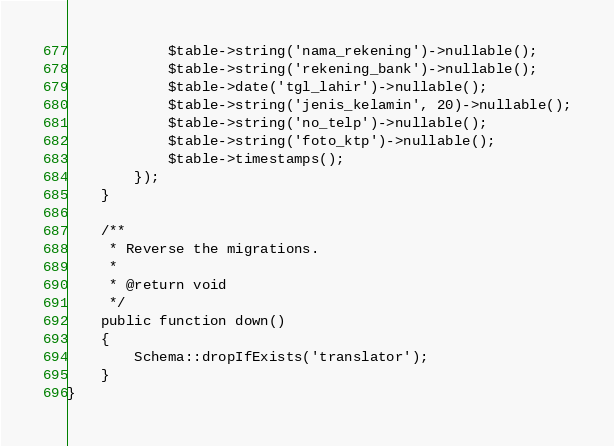<code> <loc_0><loc_0><loc_500><loc_500><_PHP_>            $table->string('nama_rekening')->nullable();
            $table->string('rekening_bank')->nullable();
            $table->date('tgl_lahir')->nullable();
            $table->string('jenis_kelamin', 20)->nullable();
            $table->string('no_telp')->nullable();
            $table->string('foto_ktp')->nullable();
            $table->timestamps();
        });
    }

    /**
     * Reverse the migrations.
     *
     * @return void
     */
    public function down()
    {
        Schema::dropIfExists('translator');
    }
}
</code> 